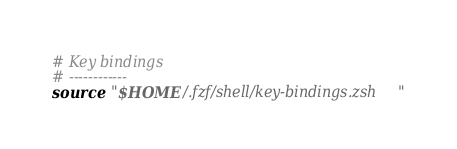<code> <loc_0><loc_0><loc_500><loc_500><_Bash_># Key bindings
# ------------
source "$HOME/.fzf/shell/key-bindings.zsh"
</code> 